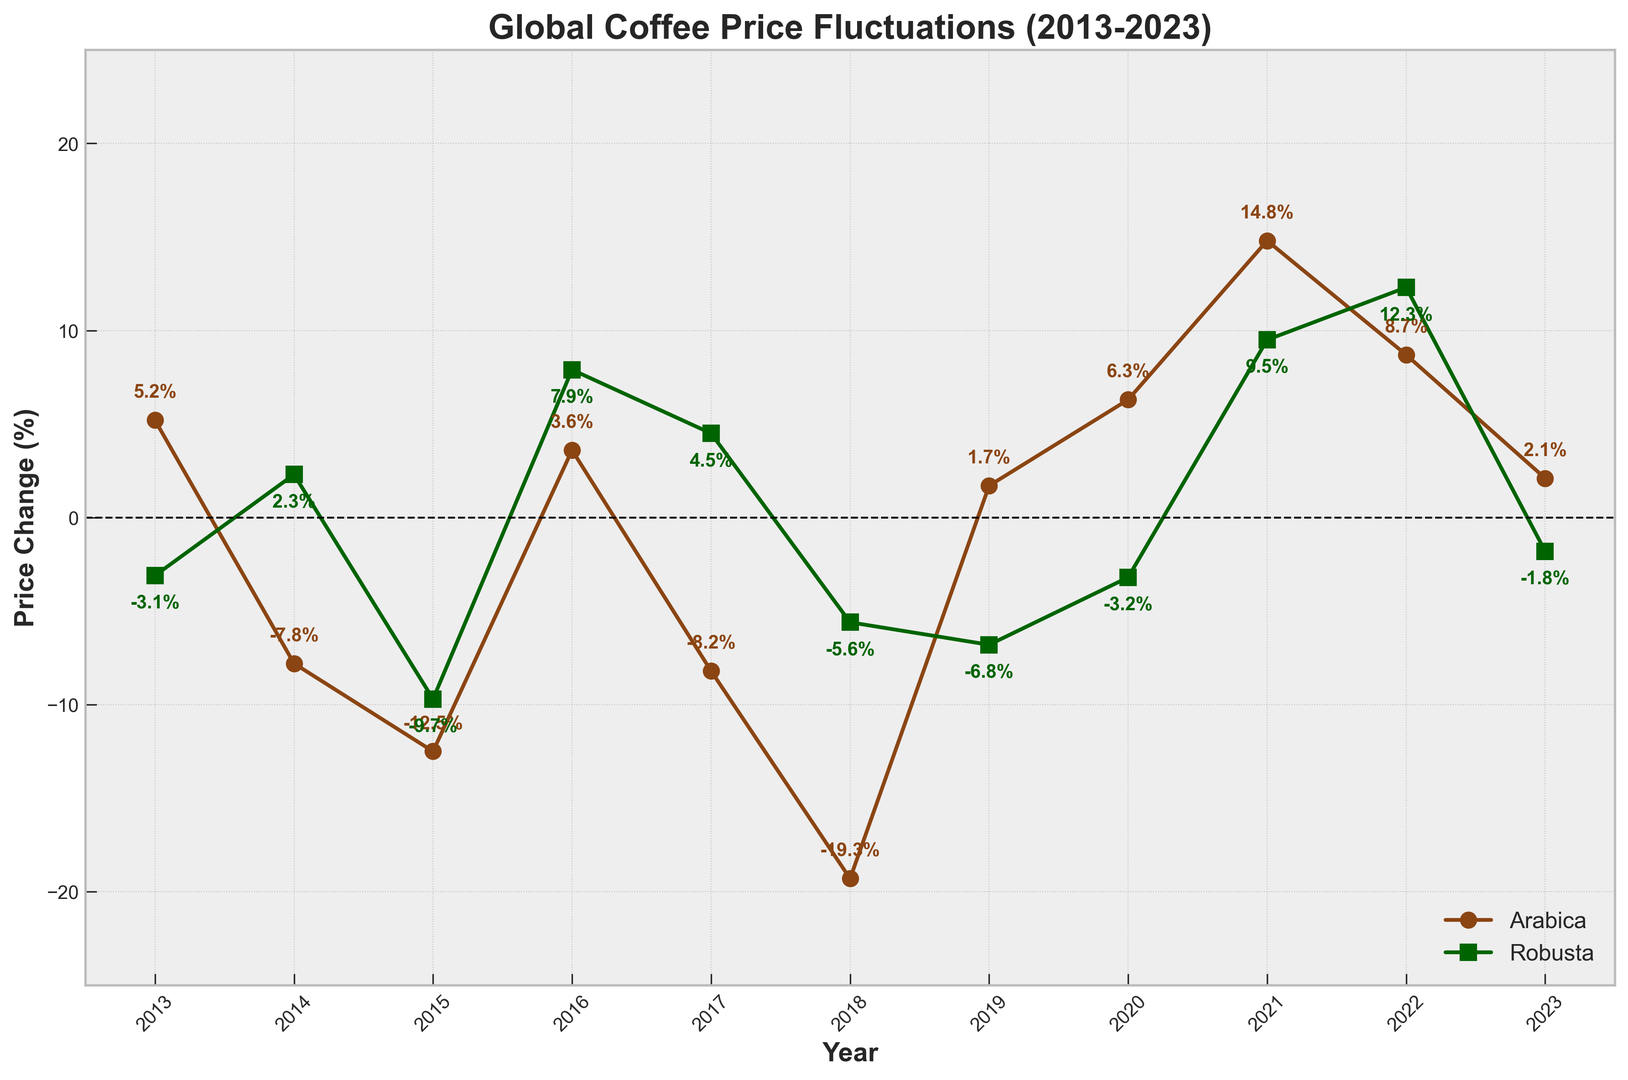What's the highest price change for Arabica coffee in the past decade? To find the highest price change for Arabica coffee, look for the peak value on the Arabica line plot. The highest point is at 14.8% in the year 2021.
Answer: 14.8% In which year did both Arabica and Robusta coffee experience a positive price change? Check the plot for years where both lines are above the zero line. In 2016, both Arabica (3.6%) and Robusta (7.9%) had positive price changes.
Answer: 2016 Which year saw the largest negative price change for Robusta coffee? Identify the lowest point on the Robusta line plot. The largest negative price change for Robusta occurred in 2019 with a value of -6.8%.
Answer: 2019 In which years did Arabica coffee experience a price increase? Look for years where the Arabica line is above the zero line. The years with positive price changes for Arabica are 2013, 2016, 2019, 2020, 2021, 2022, and 2023.
Answer: 2013, 2016, 2019, 2020, 2021, 2022, 2023 How many times did the price change for Robusta coffee fall below the zero line? Count the instances where the Robusta line is below zero. The price change for Robusta fell below zero in 2013, 2015, 2018, 2019, 2020, and 2023.
Answer: 6 times What was the average price change for Arabica coffee from 2018 to 2023? Calculate the average price by summing the values from 2018 (−19.3), 2019 (1.7), 2020 (6.3), 2021 (14.8), 2022 (8.7), and 2023 (2.1), then divide by the number of years. Average = (−19.3 + 1.7 + 6.3 + 14.8 + 8.7 + 2.1) / 6 = 2.38%.
Answer: 2.38% Which year showed the greatest discrepancy between Arabica and Robusta price changes? Calculate the absolute difference between Arabica and Robusta for each year, and find the largest one. In 2018, Arabica (−19.3%) and Robusta (−5.6%) show the largest discrepancy of 13.7 percentage points.
Answer: 2018 How did the price change for Arabica coffee in 2015 compare to Robusta coffee? Check the 2015 values on the plot. Arabica experienced a −12.5% change, while Robusta had a −9.7% change. Arabica had a greater price decrease than Robusta.
Answer: Arabica decreased more Which coffee variety had a positive price change more frequently? Count the instances where the lines for each variety are above the zero line. Arabica had positive price changes in 7 years, whereas Robusta had positive changes in 4 years.
Answer: Arabica Was there any year when Robusta coffee had a positive price change but Arabica did not? Identify years where the Robusta line is above zero but the Arabica line is below zero. The only such year is 2014.
Answer: 2014 